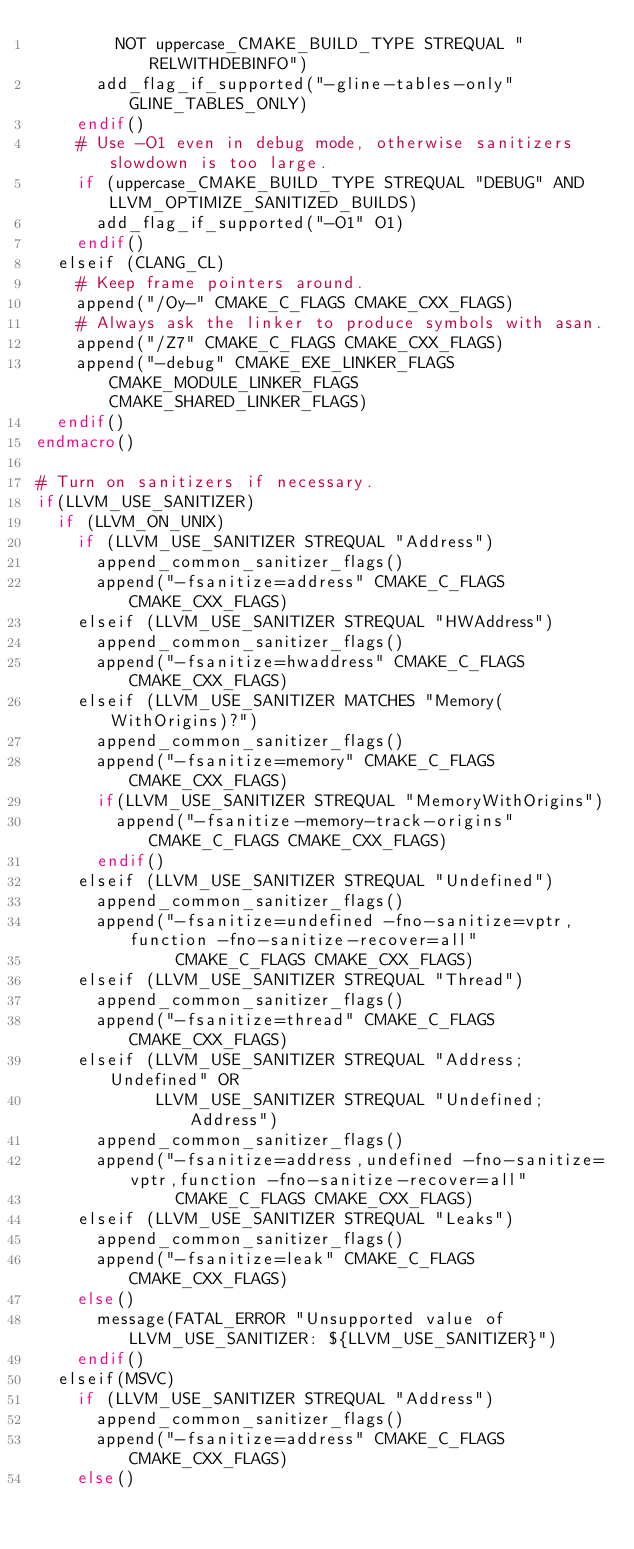Convert code to text. <code><loc_0><loc_0><loc_500><loc_500><_CMake_>        NOT uppercase_CMAKE_BUILD_TYPE STREQUAL "RELWITHDEBINFO")
      add_flag_if_supported("-gline-tables-only" GLINE_TABLES_ONLY)
    endif()
    # Use -O1 even in debug mode, otherwise sanitizers slowdown is too large.
    if (uppercase_CMAKE_BUILD_TYPE STREQUAL "DEBUG" AND LLVM_OPTIMIZE_SANITIZED_BUILDS)
      add_flag_if_supported("-O1" O1)
    endif()
  elseif (CLANG_CL)
    # Keep frame pointers around.
    append("/Oy-" CMAKE_C_FLAGS CMAKE_CXX_FLAGS)
    # Always ask the linker to produce symbols with asan.
    append("/Z7" CMAKE_C_FLAGS CMAKE_CXX_FLAGS)
    append("-debug" CMAKE_EXE_LINKER_FLAGS CMAKE_MODULE_LINKER_FLAGS CMAKE_SHARED_LINKER_FLAGS)
  endif()
endmacro()

# Turn on sanitizers if necessary.
if(LLVM_USE_SANITIZER)
  if (LLVM_ON_UNIX)
    if (LLVM_USE_SANITIZER STREQUAL "Address")
      append_common_sanitizer_flags()
      append("-fsanitize=address" CMAKE_C_FLAGS CMAKE_CXX_FLAGS)
    elseif (LLVM_USE_SANITIZER STREQUAL "HWAddress")
      append_common_sanitizer_flags()
      append("-fsanitize=hwaddress" CMAKE_C_FLAGS CMAKE_CXX_FLAGS)
    elseif (LLVM_USE_SANITIZER MATCHES "Memory(WithOrigins)?")
      append_common_sanitizer_flags()
      append("-fsanitize=memory" CMAKE_C_FLAGS CMAKE_CXX_FLAGS)
      if(LLVM_USE_SANITIZER STREQUAL "MemoryWithOrigins")
        append("-fsanitize-memory-track-origins" CMAKE_C_FLAGS CMAKE_CXX_FLAGS)
      endif()
    elseif (LLVM_USE_SANITIZER STREQUAL "Undefined")
      append_common_sanitizer_flags()
      append("-fsanitize=undefined -fno-sanitize=vptr,function -fno-sanitize-recover=all"
              CMAKE_C_FLAGS CMAKE_CXX_FLAGS)
    elseif (LLVM_USE_SANITIZER STREQUAL "Thread")
      append_common_sanitizer_flags()
      append("-fsanitize=thread" CMAKE_C_FLAGS CMAKE_CXX_FLAGS)
    elseif (LLVM_USE_SANITIZER STREQUAL "Address;Undefined" OR
            LLVM_USE_SANITIZER STREQUAL "Undefined;Address")
      append_common_sanitizer_flags()
      append("-fsanitize=address,undefined -fno-sanitize=vptr,function -fno-sanitize-recover=all"
              CMAKE_C_FLAGS CMAKE_CXX_FLAGS)
    elseif (LLVM_USE_SANITIZER STREQUAL "Leaks")
      append_common_sanitizer_flags()
      append("-fsanitize=leak" CMAKE_C_FLAGS CMAKE_CXX_FLAGS)
    else()
      message(FATAL_ERROR "Unsupported value of LLVM_USE_SANITIZER: ${LLVM_USE_SANITIZER}")
    endif()
  elseif(MSVC)
    if (LLVM_USE_SANITIZER STREQUAL "Address")
      append_common_sanitizer_flags()
      append("-fsanitize=address" CMAKE_C_FLAGS CMAKE_CXX_FLAGS)
    else()</code> 